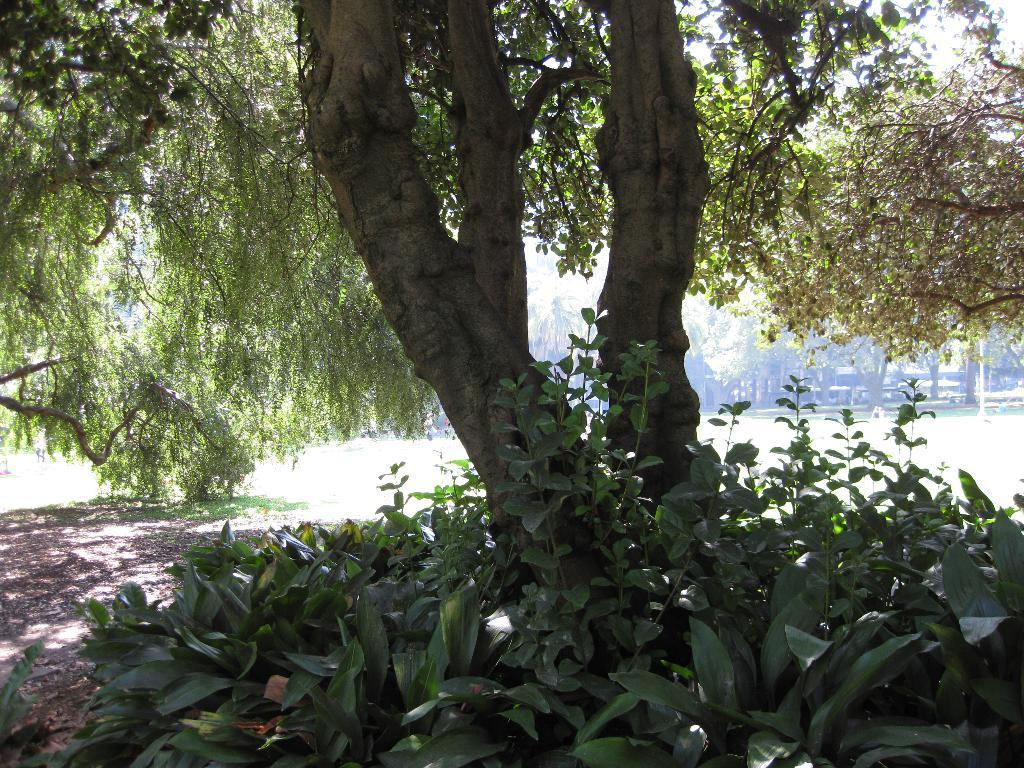What type of vegetation is at the bottom of the image? There are small plants with leaves at the bottom of the image. What is located between the small plants? There is a tree between the small plants. What can be seen in the background of the image? There are trees visible in the background of the image. What type of rhythm can be heard coming from the room in the image? There is no room or any sounds mentioned in the image, so it's not possible to determine what rhythm might be heard. 